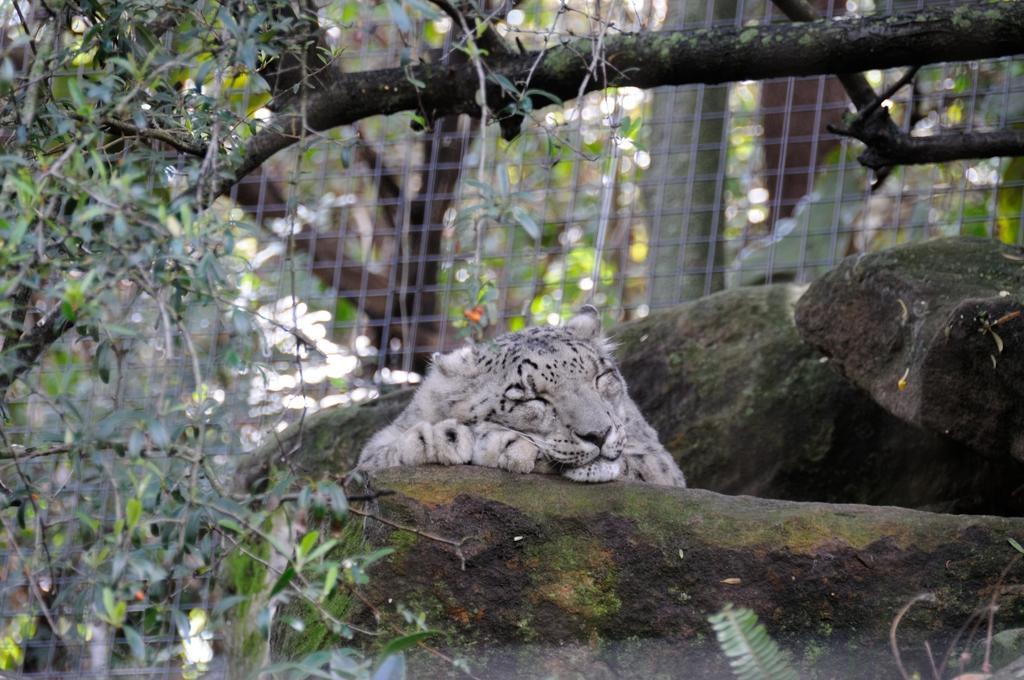Please provide a concise description of this image. A tiger is sleeping, these are trees and a rock. 